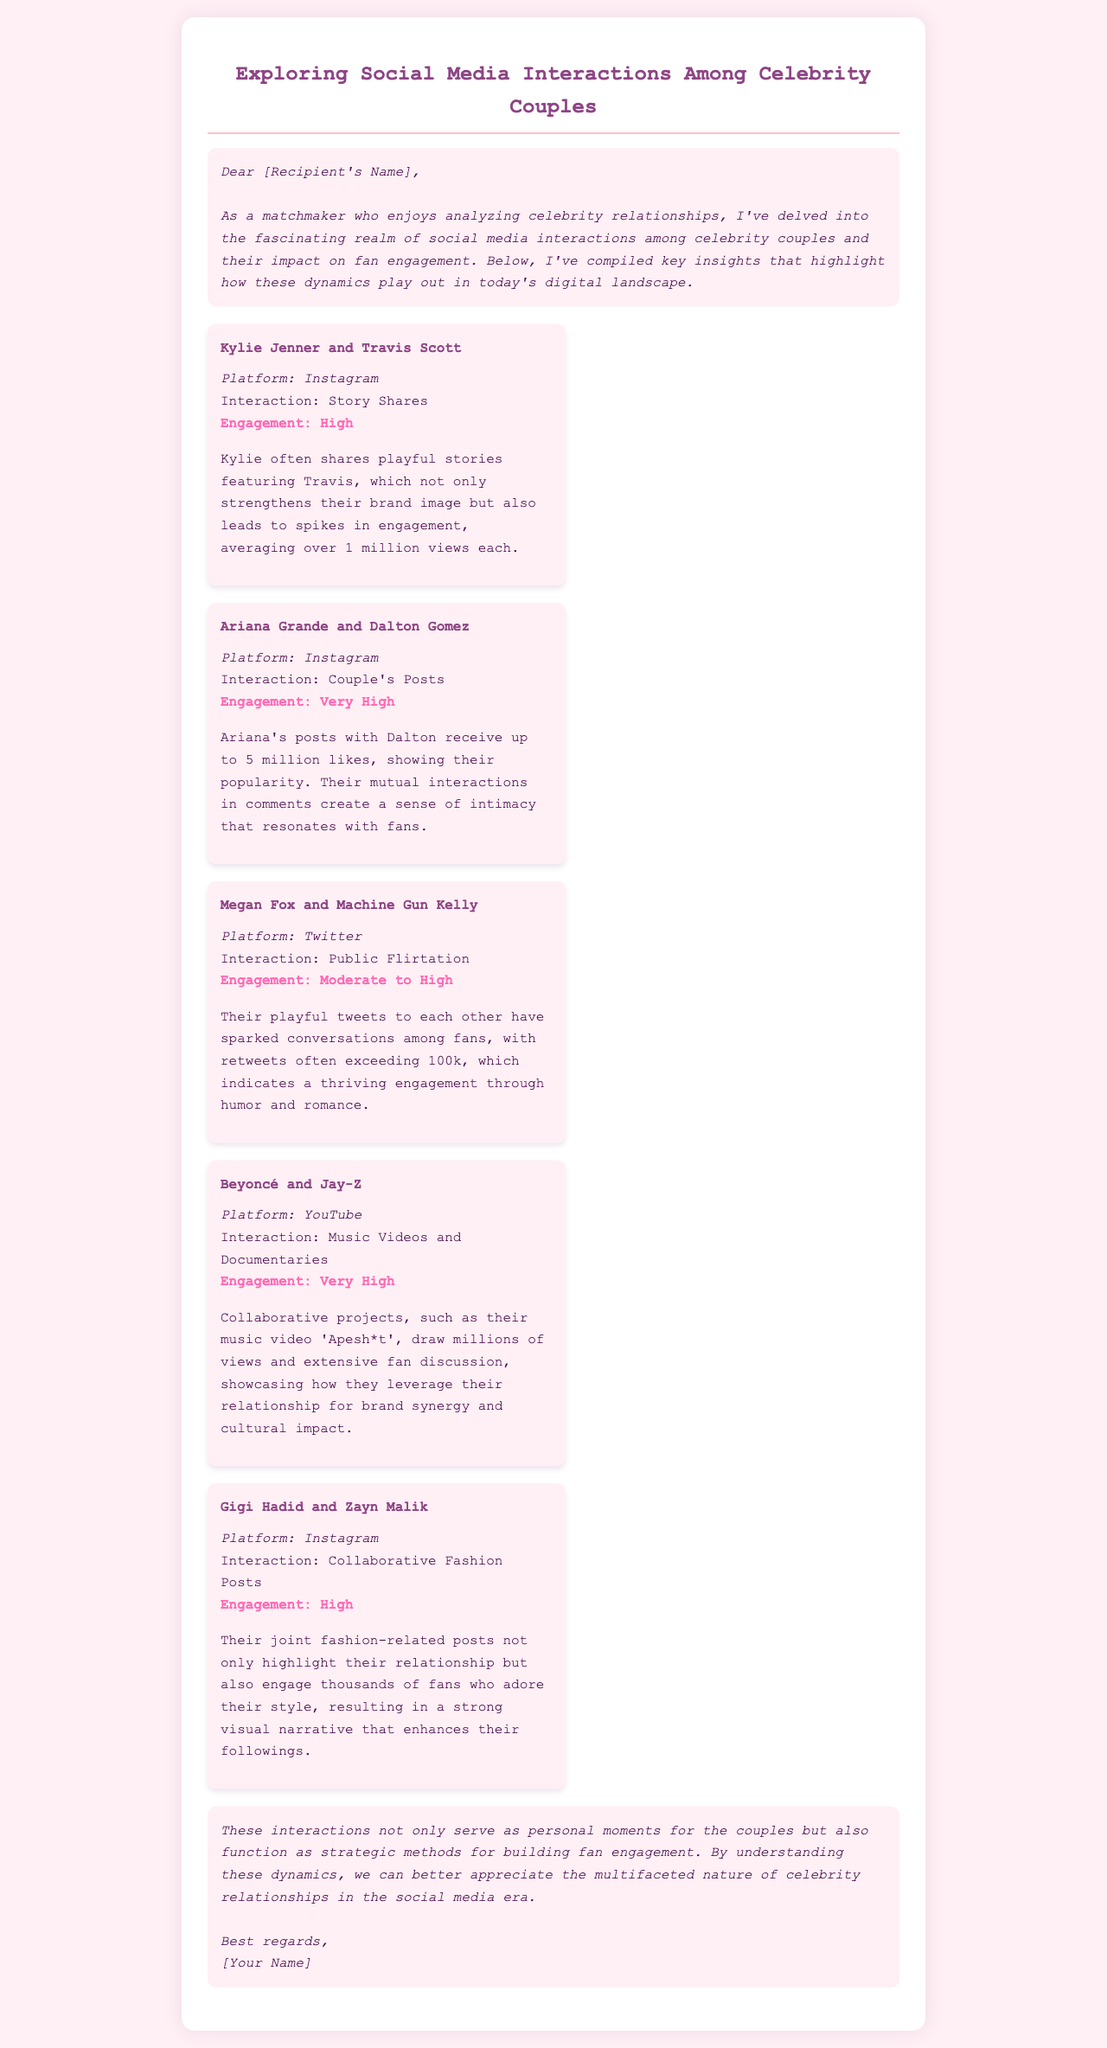What is the main focus of this document? The main focus of the document is on social media interactions among celebrity couples and their impact on fan engagement.
Answer: Social media interactions Who often shares playful stories featuring Travis? The document states that Kylie Jenner often shares playful stories featuring Travis Scott.
Answer: Kylie Jenner Which couple's Instagram posts receive up to 5 million likes? The couple whose Instagram posts receive up to 5 million likes is Ariana Grande and Dalton Gomez.
Answer: Ariana Grande and Dalton Gomez What type of interactions do Megan Fox and Machine Gun Kelly have on Twitter? Megan Fox and Machine Gun Kelly engage in public flirtation on Twitter.
Answer: Public flirtation How many views did the collaborative music video 'Apesh*t' draw? The document mentions that their music video 'Apesh*t' draws millions of views.
Answer: Millions What engagement level is associated with Gigi Hadid and Zayn Malik's collaborative fashion posts? The engagement level associated with Gigi Hadid and Zayn Malik's collaborative fashion posts is high.
Answer: High Which social media platform is highlighted for Beyoncé and Jay-Z's interactions? The highlighted platform for Beyoncé and Jay-Z's interactions is YouTube.
Answer: YouTube What do these interactions serve as for the couples? These interactions serve as personal moments for the couples and also as strategic methods for building fan engagement.
Answer: Personal moments 